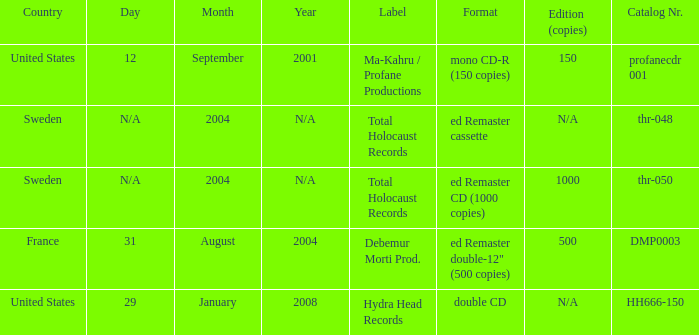Which country has the format ed Remaster double-12" (500 copies)? France. 